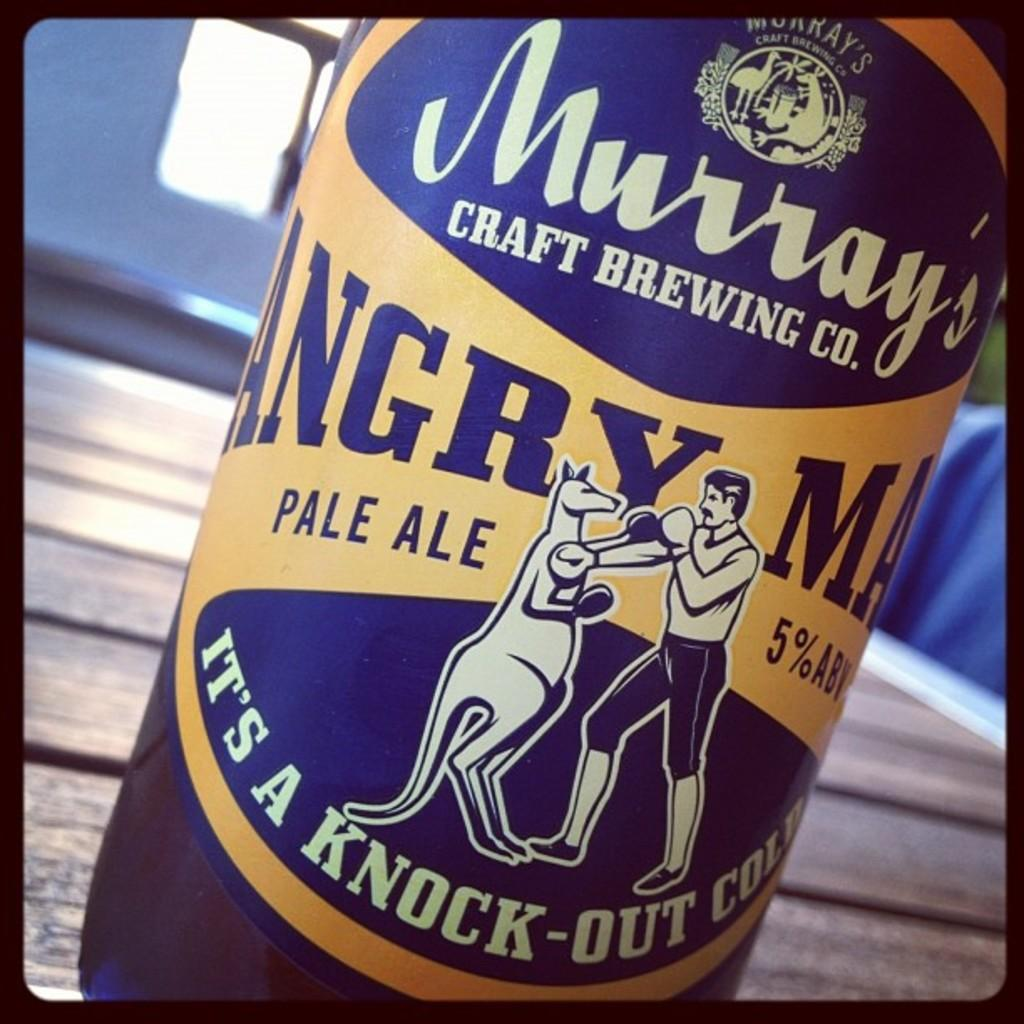<image>
Offer a succinct explanation of the picture presented. Murray's Craft Brewing Company that says Angry Man Pale Ale 5% ABV, Its a Knock-Out Cold. 